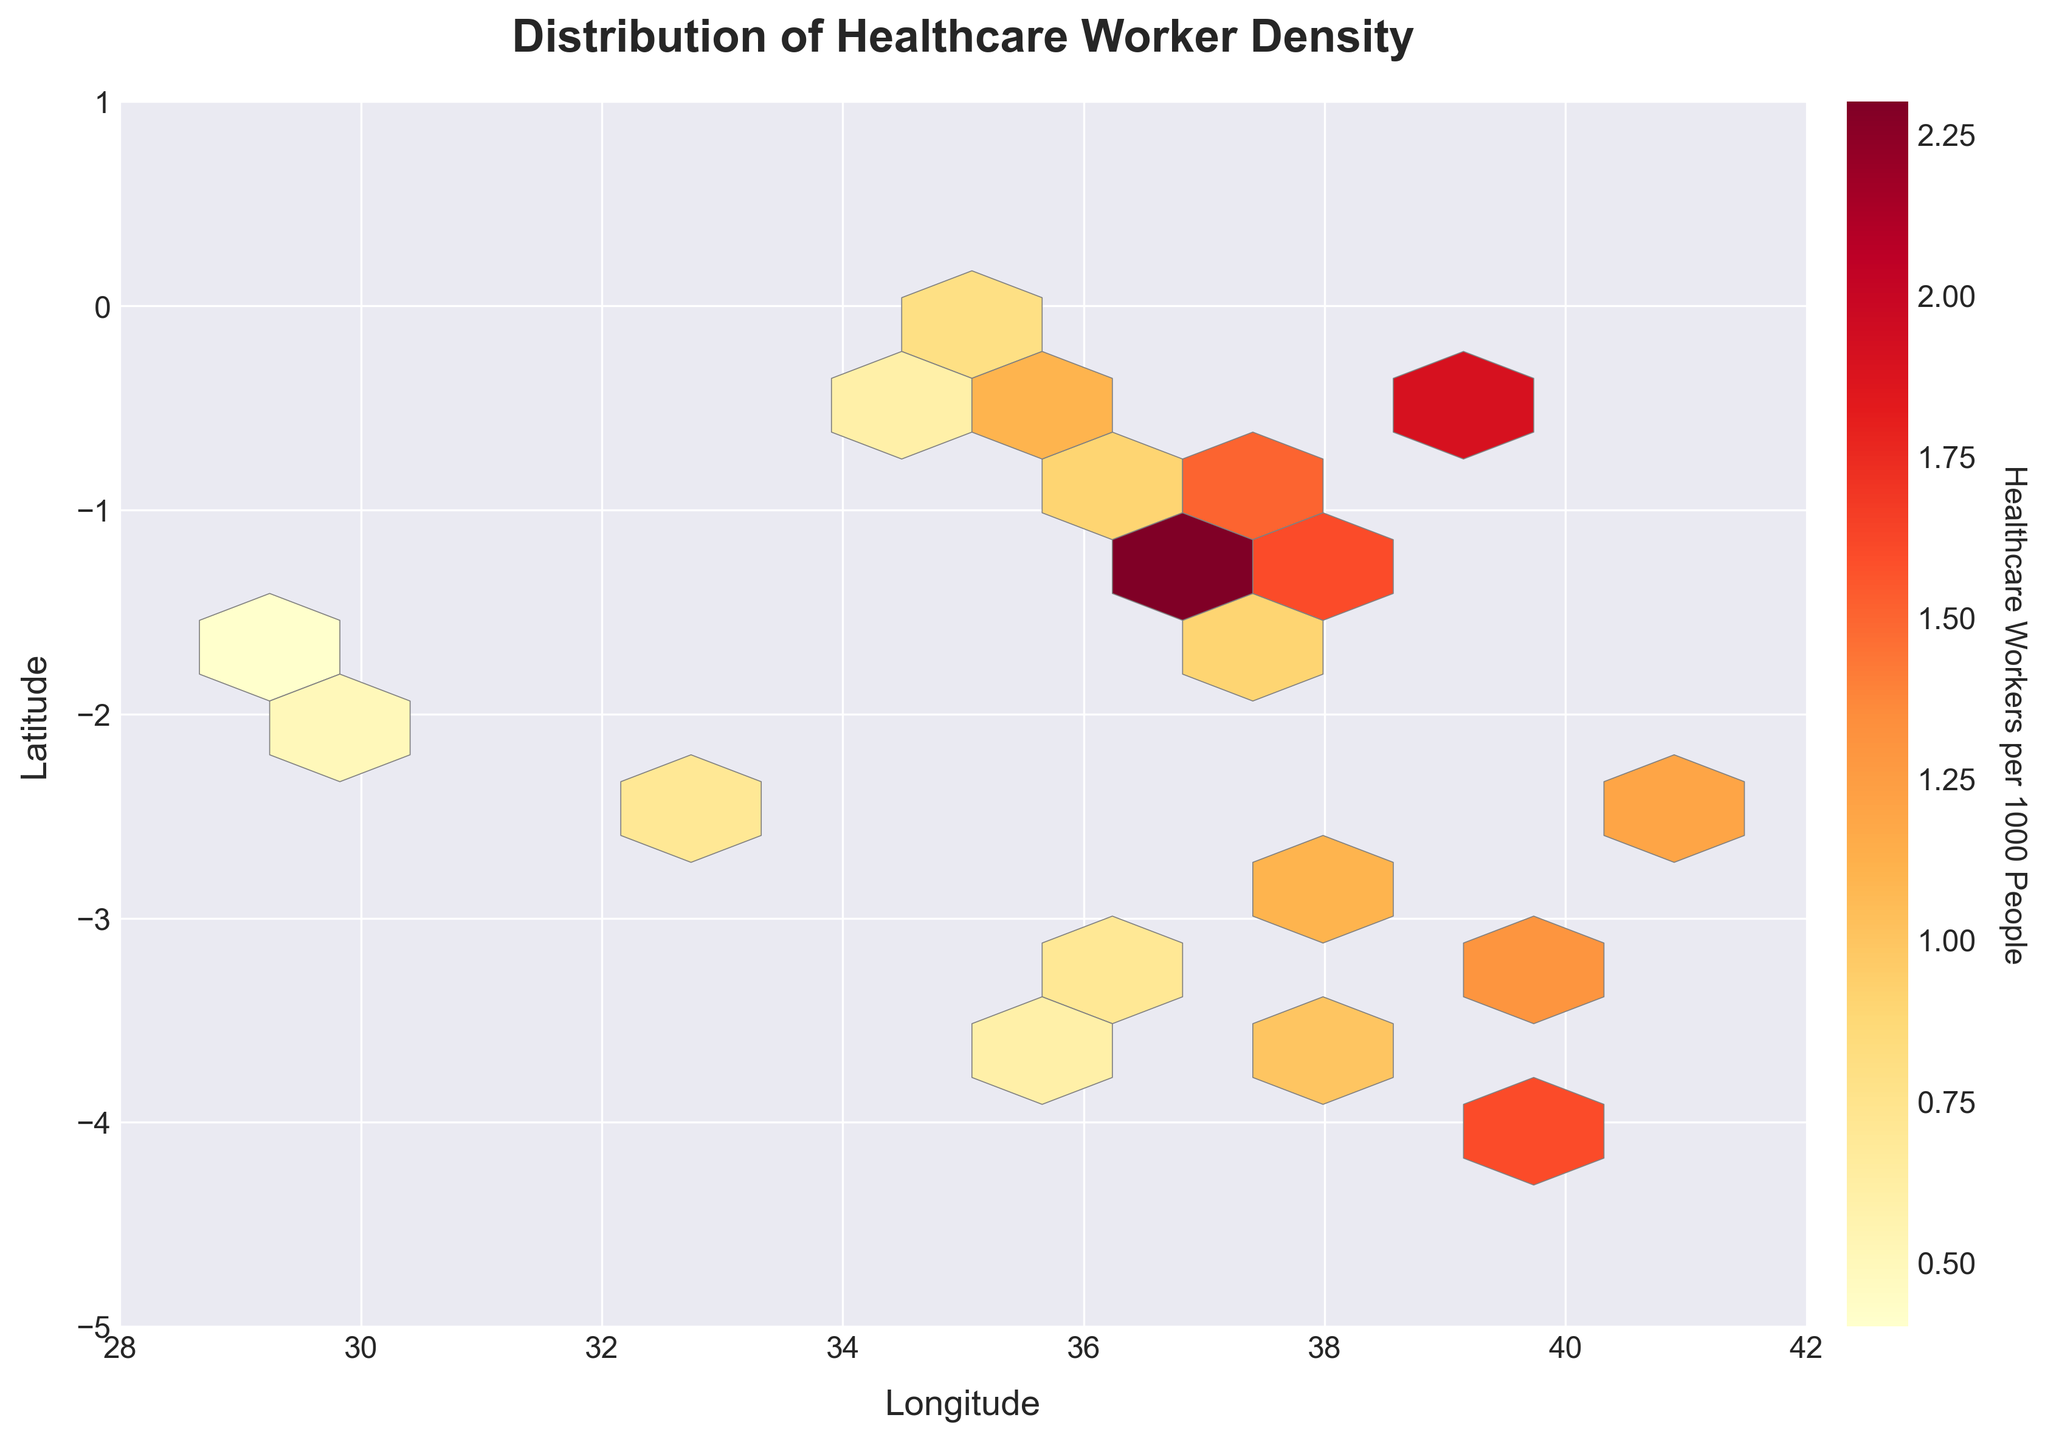what is the title of the figure? The title is written at the top-center of the figure. It reads "Distribution of Healthcare Worker Density".
Answer: Distribution of Healthcare Worker Density What does the color gradient represent in the figure? The color gradient is indicated by the color bar to the right of the figure. It represents the number of healthcare workers per 1000 people, with lighter colors indicating fewer healthcare workers and darker colors indicating more healthcare workers.
Answer: Number of healthcare workers per 1000 people Which area has the highest density of healthcare workers? The areas with the darkest color in the hexbin plot indicate the highest density of healthcare workers. Identify the darkest hexagons on the plot.
Answer: Around (36.8219, -1.2921) Which area has the lowest density of healthcare workers? The areas with the lightest color in the hexbin plot indicate the lowest density of healthcare workers. Identify the lightest hexagons on the plot.
Answer: Around (30.0586, -1.9449) and (29.2431, -1.6857) What is the color bar label, and what does it signify? The color bar label is adjacent to the color gradient on the right of the figure. It reads "Healthcare Workers per 1000 People", signifying that the color represents the density of healthcare workers per 1000 people.
Answer: Healthcare Workers per 1000 People How many major latitudinal tick marks are on the y-axis? By counting the tick marks on the y-axis, we can determine the number of major latitudinal divisions. The tick marks are located at regular intervals along the y-axis.
Answer: 7 Is there a concentration of underserved regions with fewer than 1 healthcare worker per 1000 people? If so, where are they located? By looking at the lighter-colored hexagons, we can identify regions with fewer than 1 healthcare worker per 1000 people. These hexagons are predominantly located at more negative latitudes and longitudes.
Answer: Yes, around (30.0586, -1.9449) and (32.9303, -2.5559) Do areas with higher longitude generally have a higher density of healthcare workers? By observing the color gradient from left to right across the hexbin plot, we can assess whether there is a trend of increasing healthcare worker density with higher longitudes.
Answer: No clear trend What are the longitude and latitude ranges displayed in the hexbin plot? By examining the x-axis and y-axis limits, we can determine the minimum and maximum values for longitude and latitude ranges displayed.
Answer: Longitude: 28 to 42, Latitude: -5 to 1 How does the density of healthcare workers change as we move northward from latitude -5 to 1 along longitude 36? By following the hexagons along longitude 36 from latitude -5 to 1, we can observe changes in color intensity, indicating variations in healthcare worker density.
Answer: Generally increases 